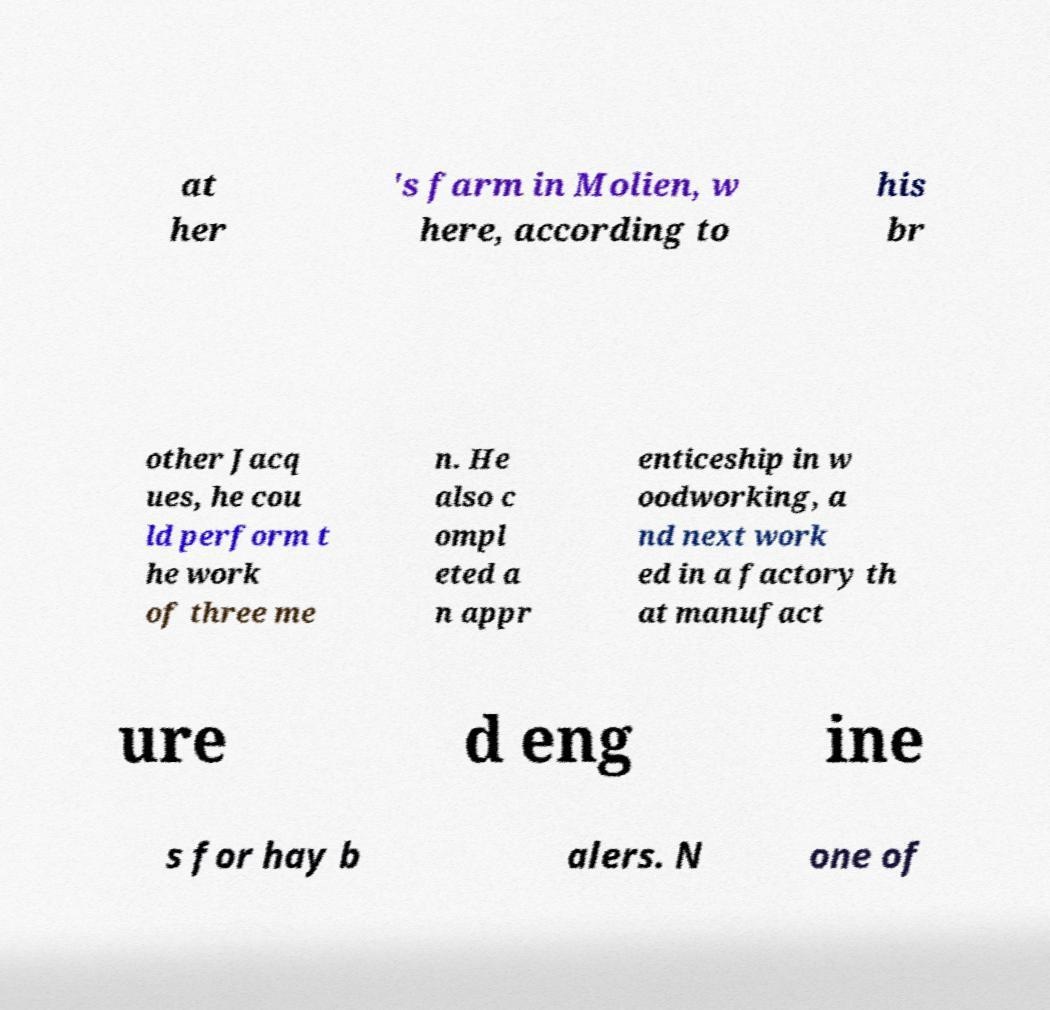What messages or text are displayed in this image? I need them in a readable, typed format. at her 's farm in Molien, w here, according to his br other Jacq ues, he cou ld perform t he work of three me n. He also c ompl eted a n appr enticeship in w oodworking, a nd next work ed in a factory th at manufact ure d eng ine s for hay b alers. N one of 